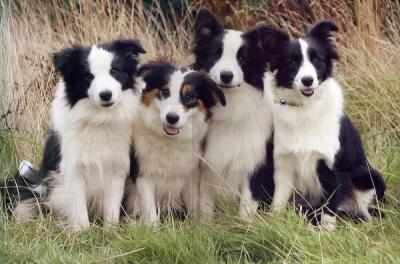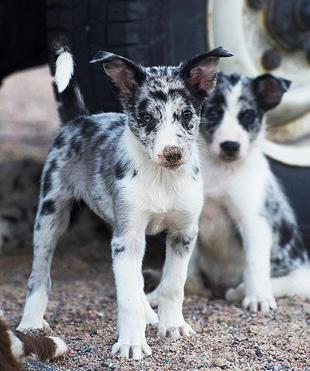The first image is the image on the left, the second image is the image on the right. Assess this claim about the two images: "Some of the dogs are sitting down.". Correct or not? Answer yes or no. Yes. The first image is the image on the left, the second image is the image on the right. Analyze the images presented: Is the assertion "One image contains four or more dogs that are grouped together in a pose." valid? Answer yes or no. Yes. 